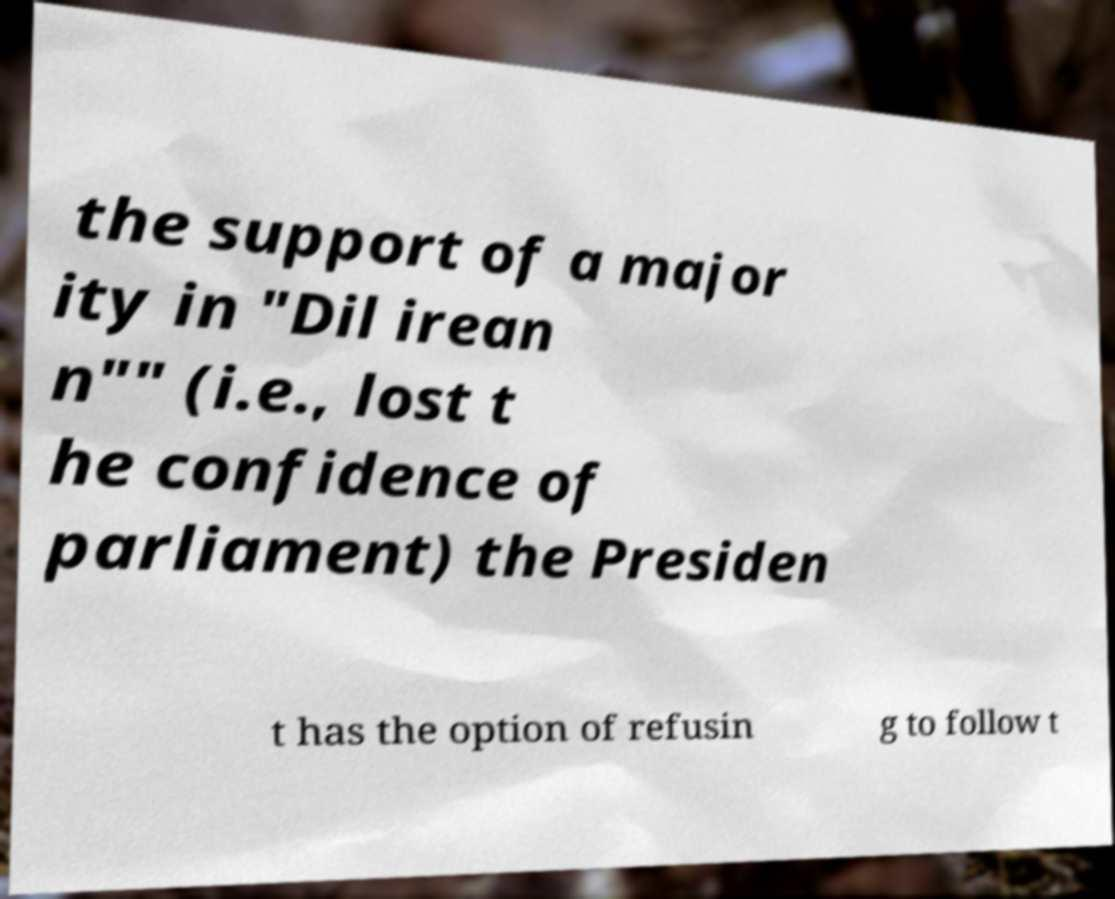Can you accurately transcribe the text from the provided image for me? the support of a major ity in "Dil irean n"" (i.e., lost t he confidence of parliament) the Presiden t has the option of refusin g to follow t 